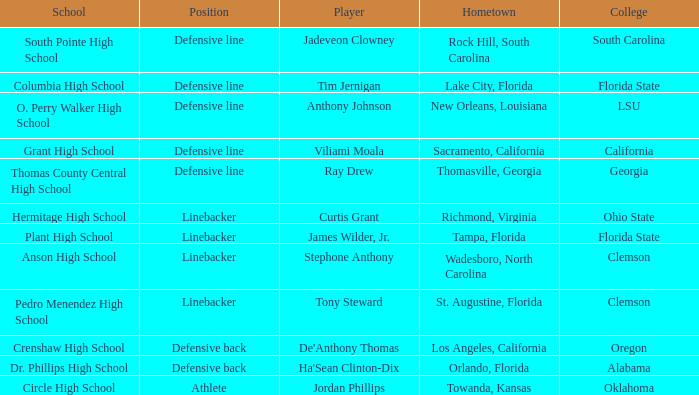Which college is Jordan Phillips playing for? Oklahoma. 